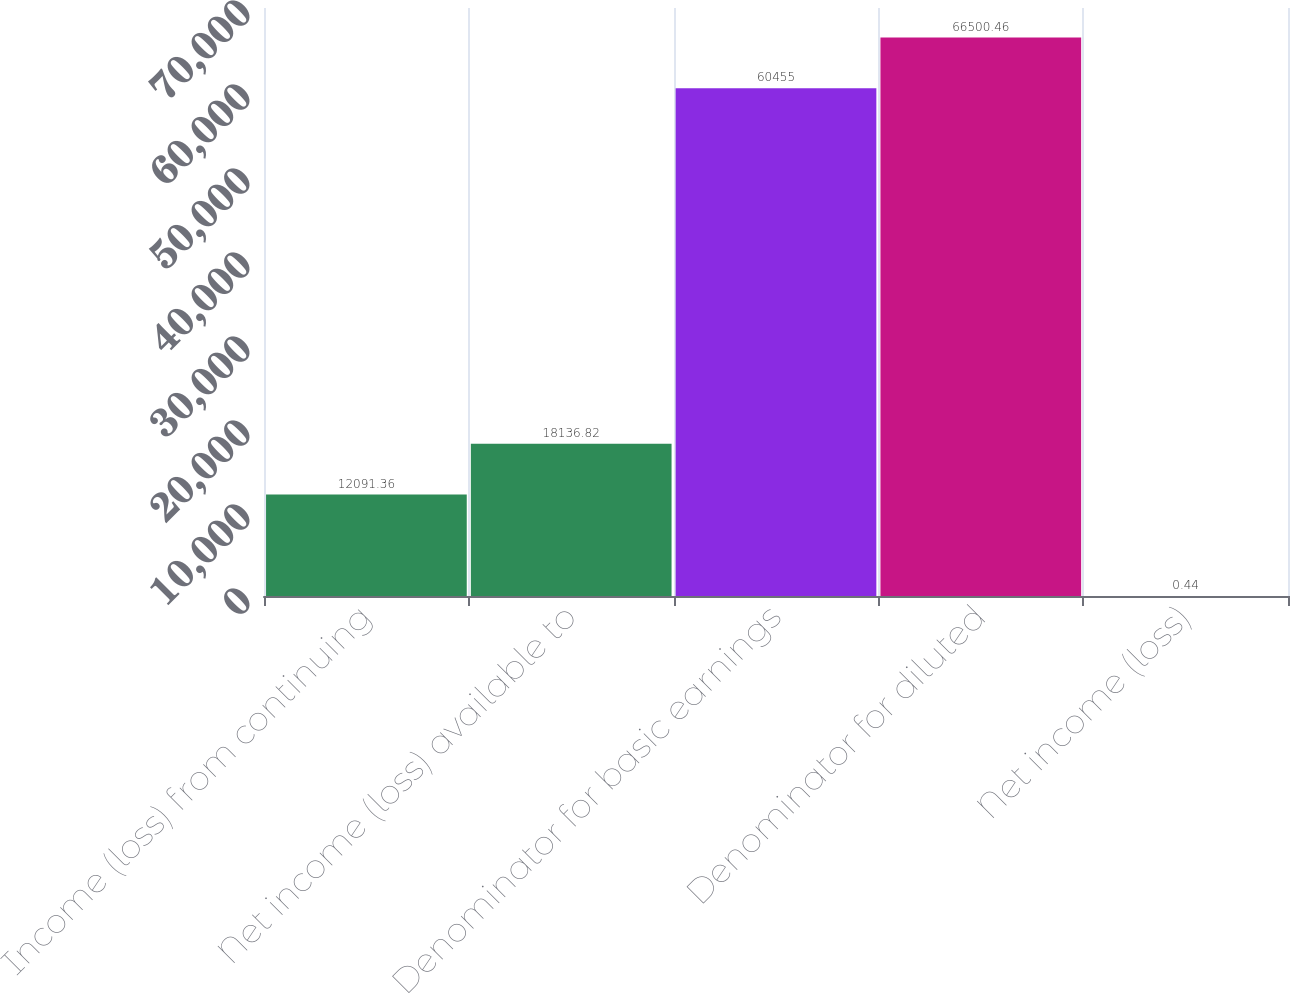<chart> <loc_0><loc_0><loc_500><loc_500><bar_chart><fcel>Income (loss) from continuing<fcel>Net income (loss) available to<fcel>Denominator for basic earnings<fcel>Denominator for diluted<fcel>Net income (loss)<nl><fcel>12091.4<fcel>18136.8<fcel>60455<fcel>66500.5<fcel>0.44<nl></chart> 